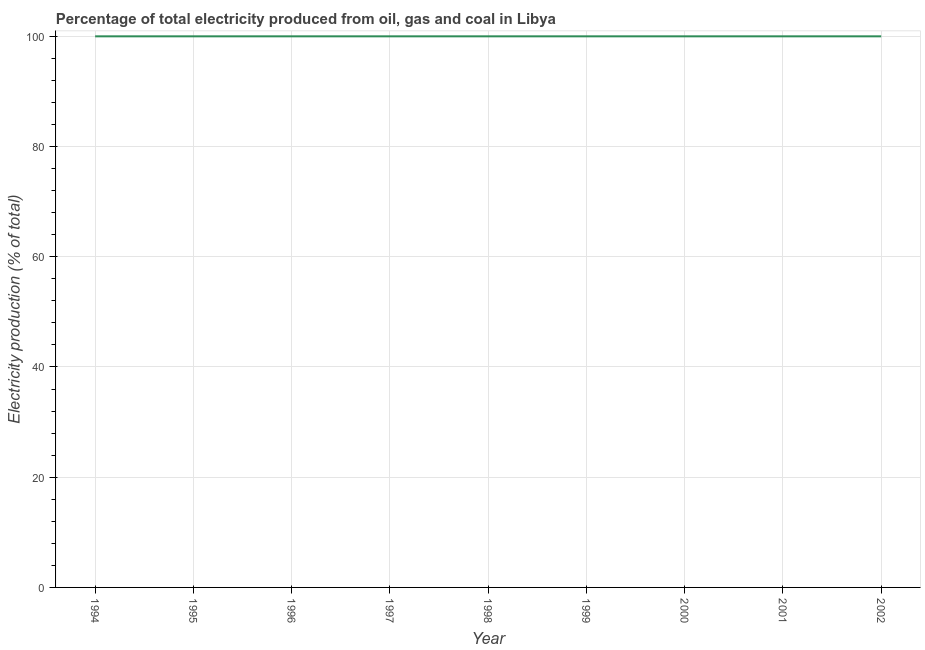What is the electricity production in 2000?
Your answer should be compact. 100. Across all years, what is the maximum electricity production?
Keep it short and to the point. 100. Across all years, what is the minimum electricity production?
Ensure brevity in your answer.  100. In which year was the electricity production maximum?
Offer a terse response. 1994. What is the sum of the electricity production?
Your answer should be very brief. 900. What is the average electricity production per year?
Provide a short and direct response. 100. What is the median electricity production?
Your response must be concise. 100. In how many years, is the electricity production greater than 16 %?
Keep it short and to the point. 9. What is the ratio of the electricity production in 1997 to that in 1999?
Make the answer very short. 1. Is the difference between the electricity production in 1995 and 1997 greater than the difference between any two years?
Give a very brief answer. Yes. Is the sum of the electricity production in 1998 and 2000 greater than the maximum electricity production across all years?
Keep it short and to the point. Yes. In how many years, is the electricity production greater than the average electricity production taken over all years?
Ensure brevity in your answer.  0. Does the electricity production monotonically increase over the years?
Offer a terse response. No. How many lines are there?
Provide a short and direct response. 1. How many years are there in the graph?
Your answer should be compact. 9. Does the graph contain grids?
Your answer should be very brief. Yes. What is the title of the graph?
Provide a succinct answer. Percentage of total electricity produced from oil, gas and coal in Libya. What is the label or title of the X-axis?
Provide a short and direct response. Year. What is the label or title of the Y-axis?
Ensure brevity in your answer.  Electricity production (% of total). What is the Electricity production (% of total) of 1994?
Provide a succinct answer. 100. What is the Electricity production (% of total) in 1995?
Your answer should be compact. 100. What is the Electricity production (% of total) in 1998?
Make the answer very short. 100. What is the Electricity production (% of total) of 2000?
Give a very brief answer. 100. What is the Electricity production (% of total) of 2002?
Ensure brevity in your answer.  100. What is the difference between the Electricity production (% of total) in 1994 and 1995?
Make the answer very short. 0. What is the difference between the Electricity production (% of total) in 1994 and 1997?
Make the answer very short. 0. What is the difference between the Electricity production (% of total) in 1994 and 1999?
Keep it short and to the point. 0. What is the difference between the Electricity production (% of total) in 1994 and 2000?
Give a very brief answer. 0. What is the difference between the Electricity production (% of total) in 1994 and 2002?
Your answer should be very brief. 0. What is the difference between the Electricity production (% of total) in 1995 and 1997?
Ensure brevity in your answer.  0. What is the difference between the Electricity production (% of total) in 1995 and 1998?
Your answer should be very brief. 0. What is the difference between the Electricity production (% of total) in 1995 and 1999?
Provide a succinct answer. 0. What is the difference between the Electricity production (% of total) in 1995 and 2000?
Give a very brief answer. 0. What is the difference between the Electricity production (% of total) in 1995 and 2001?
Give a very brief answer. 0. What is the difference between the Electricity production (% of total) in 1995 and 2002?
Ensure brevity in your answer.  0. What is the difference between the Electricity production (% of total) in 1996 and 1998?
Ensure brevity in your answer.  0. What is the difference between the Electricity production (% of total) in 1996 and 1999?
Keep it short and to the point. 0. What is the difference between the Electricity production (% of total) in 1996 and 2002?
Your response must be concise. 0. What is the difference between the Electricity production (% of total) in 1997 and 1998?
Offer a terse response. 0. What is the difference between the Electricity production (% of total) in 1998 and 2001?
Keep it short and to the point. 0. What is the difference between the Electricity production (% of total) in 1999 and 2002?
Your response must be concise. 0. What is the difference between the Electricity production (% of total) in 2000 and 2001?
Offer a very short reply. 0. What is the difference between the Electricity production (% of total) in 2001 and 2002?
Your response must be concise. 0. What is the ratio of the Electricity production (% of total) in 1994 to that in 1995?
Make the answer very short. 1. What is the ratio of the Electricity production (% of total) in 1994 to that in 1996?
Your response must be concise. 1. What is the ratio of the Electricity production (% of total) in 1994 to that in 1998?
Ensure brevity in your answer.  1. What is the ratio of the Electricity production (% of total) in 1994 to that in 1999?
Offer a terse response. 1. What is the ratio of the Electricity production (% of total) in 1994 to that in 2002?
Your answer should be very brief. 1. What is the ratio of the Electricity production (% of total) in 1995 to that in 1998?
Keep it short and to the point. 1. What is the ratio of the Electricity production (% of total) in 1995 to that in 1999?
Offer a terse response. 1. What is the ratio of the Electricity production (% of total) in 1995 to that in 2001?
Your answer should be very brief. 1. What is the ratio of the Electricity production (% of total) in 1995 to that in 2002?
Offer a terse response. 1. What is the ratio of the Electricity production (% of total) in 1996 to that in 2000?
Ensure brevity in your answer.  1. What is the ratio of the Electricity production (% of total) in 1996 to that in 2001?
Ensure brevity in your answer.  1. What is the ratio of the Electricity production (% of total) in 1997 to that in 1999?
Offer a terse response. 1. What is the ratio of the Electricity production (% of total) in 1997 to that in 2000?
Give a very brief answer. 1. What is the ratio of the Electricity production (% of total) in 1997 to that in 2001?
Give a very brief answer. 1. What is the ratio of the Electricity production (% of total) in 1997 to that in 2002?
Give a very brief answer. 1. What is the ratio of the Electricity production (% of total) in 1999 to that in 2000?
Your response must be concise. 1. What is the ratio of the Electricity production (% of total) in 1999 to that in 2001?
Offer a terse response. 1. What is the ratio of the Electricity production (% of total) in 1999 to that in 2002?
Your answer should be very brief. 1. What is the ratio of the Electricity production (% of total) in 2000 to that in 2001?
Your answer should be very brief. 1. What is the ratio of the Electricity production (% of total) in 2000 to that in 2002?
Your answer should be very brief. 1. What is the ratio of the Electricity production (% of total) in 2001 to that in 2002?
Keep it short and to the point. 1. 